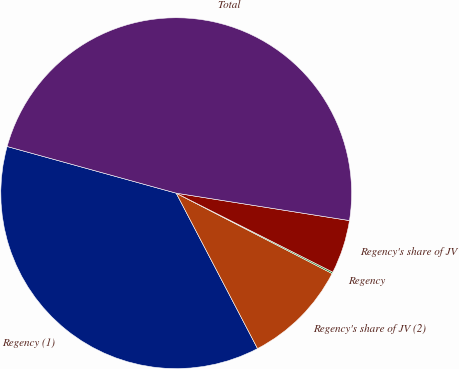Convert chart to OTSL. <chart><loc_0><loc_0><loc_500><loc_500><pie_chart><fcel>Regency (1)<fcel>Regency's share of JV (2)<fcel>Regency<fcel>Regency's share of JV<fcel>Total<nl><fcel>36.96%<fcel>9.75%<fcel>0.14%<fcel>4.94%<fcel>48.21%<nl></chart> 